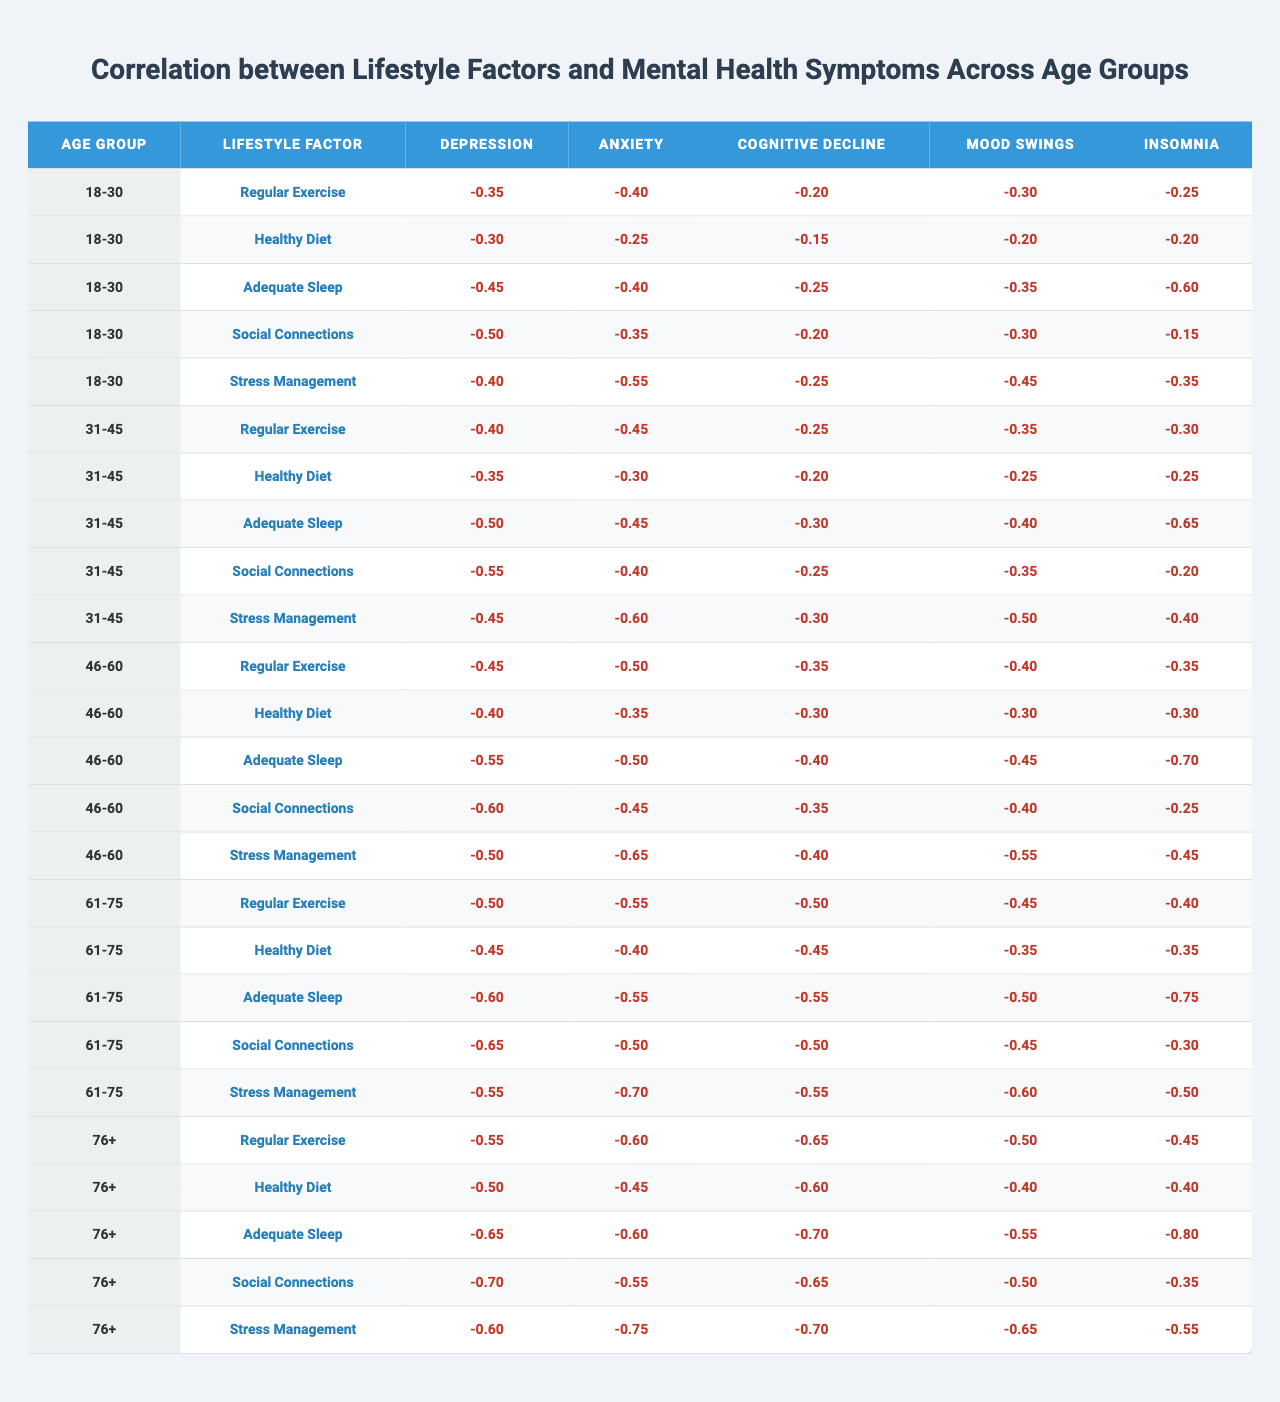What is the correlation value for Regular Exercise and Depression in the age group 31-45? In the table, I locate the age group 31-45 and find the value under Regular Exercise for Depression which is -0.40.
Answer: -0.40 What is the highest negative correlation for Insomnia across all age groups? To find the highest negative correlation for Insomnia, I examine each row under Insomnia. The most negative correlation is -0.80 found in the age group 76+.
Answer: -0.80 Which lifestyle factor shows the strongest correlation with Anxiety in the age group 61-75? I look at the Anxiety correlations in the age group 61-75, where the values are: Regular Exercise -0.55, Healthy Diet -0.40, Adequate Sleep -0.55, Social Connections -0.50, and Stress Management -0.70. The strongest correlation is -0.70 for Stress Management.
Answer: Stress Management What is the average correlation value for Cognitive Decline in the age group 46-60 across all lifestyle factors? For age group 46-60, the correlations for Cognitive Decline are: Regular Exercise -0.35, Healthy Diet -0.30, Adequate Sleep -0.40, Social Connections -0.35, and Stress Management -0.40. The sum is (-0.35 + -0.30 + -0.40 + -0.35 + -0.40) = -1.80. Then, dividing by 5 (the number of lifestyle factors) gives an average of -0.36.
Answer: -0.36 Is there any age group where Regular Exercise has a positive correlation with any mental health symptom? I review the entire table for any positive correlation values under Regular Exercise. Every correlation for Regular Exercise is negative across all age groups for each mental health symptom, which indicates there are no positive correlations.
Answer: No For which age group does a Healthy Diet show a higher correlation with Anxiety than with Depression? I find the correlation values for Healthy Diet in each age group. For 18-30: Anxiety -0.25 vs Depression -0.30; for 31-45: Anxiety -0.30 vs Depression -0.35; for 46-60: Anxiety -0.35 vs Depression -0.40; and for 61-75: Anxiety -0.40 vs Depression -0.45. In none are Anxiety greater than Depression, hence there’s no age group where Healthy Diet shows a higher correlation with Anxiety than with Depression.
Answer: No age group What is the trend of correlation values for Adequate Sleep and Mood Swings as we progress across age groups from 18-30 to 76+? Analyzing the Adequate Sleep correlations with Mood Swings across the age categories, they are -0.35 for 18-30, -0.40 for 31-45, -0.45 for 46-60, -0.50 for 61-75, and -0.55 for 76+. This reveals a trend where the correlation values are becoming increasingly negative as age increases.
Answer: Increasingly negative How do the correlations for Stress Management and Depression compare between the age groups 18-30 and 61-75? Under Stress Management, the correlation for Depression in the age group 18-30 is -0.40 while in the age group 61-75 it is -0.55. This indicates that the negative correlation with Depression is stronger in the older age group compared to the younger one.
Answer: -0.40 is less than -0.55 Which lifestyle factor shows the least negative correlation with Insomnia in the age group 46-60? Looking under Insomnia for age group 46-60, the correlations are: Regular Exercise -0.35, Healthy Diet -0.30, Adequate Sleep -0.70, Social Connections -0.25, and Stress Management -0.45. The least negative value is -0.25 for Social Connections.
Answer: Social Connections 